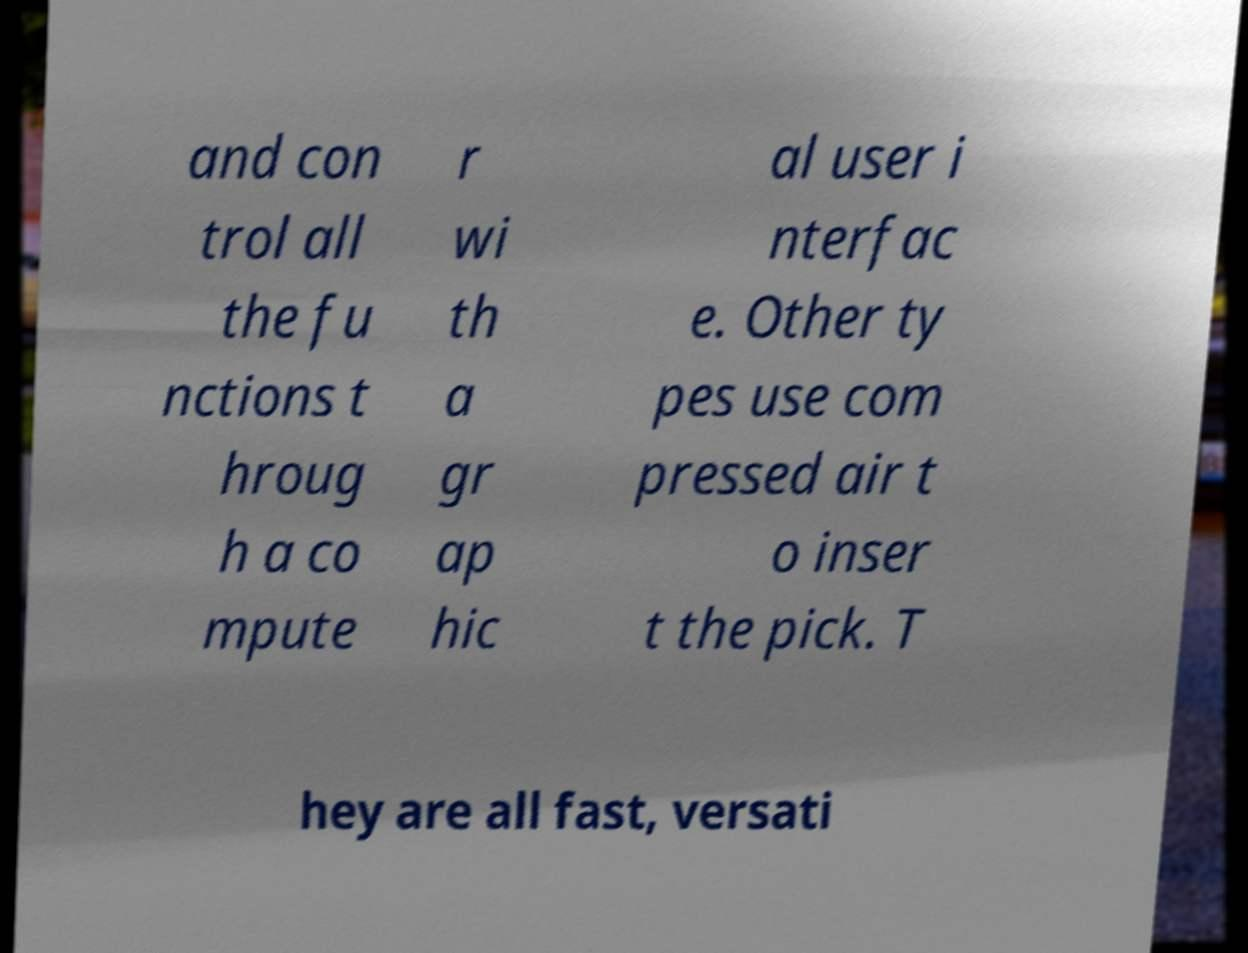There's text embedded in this image that I need extracted. Can you transcribe it verbatim? and con trol all the fu nctions t hroug h a co mpute r wi th a gr ap hic al user i nterfac e. Other ty pes use com pressed air t o inser t the pick. T hey are all fast, versati 